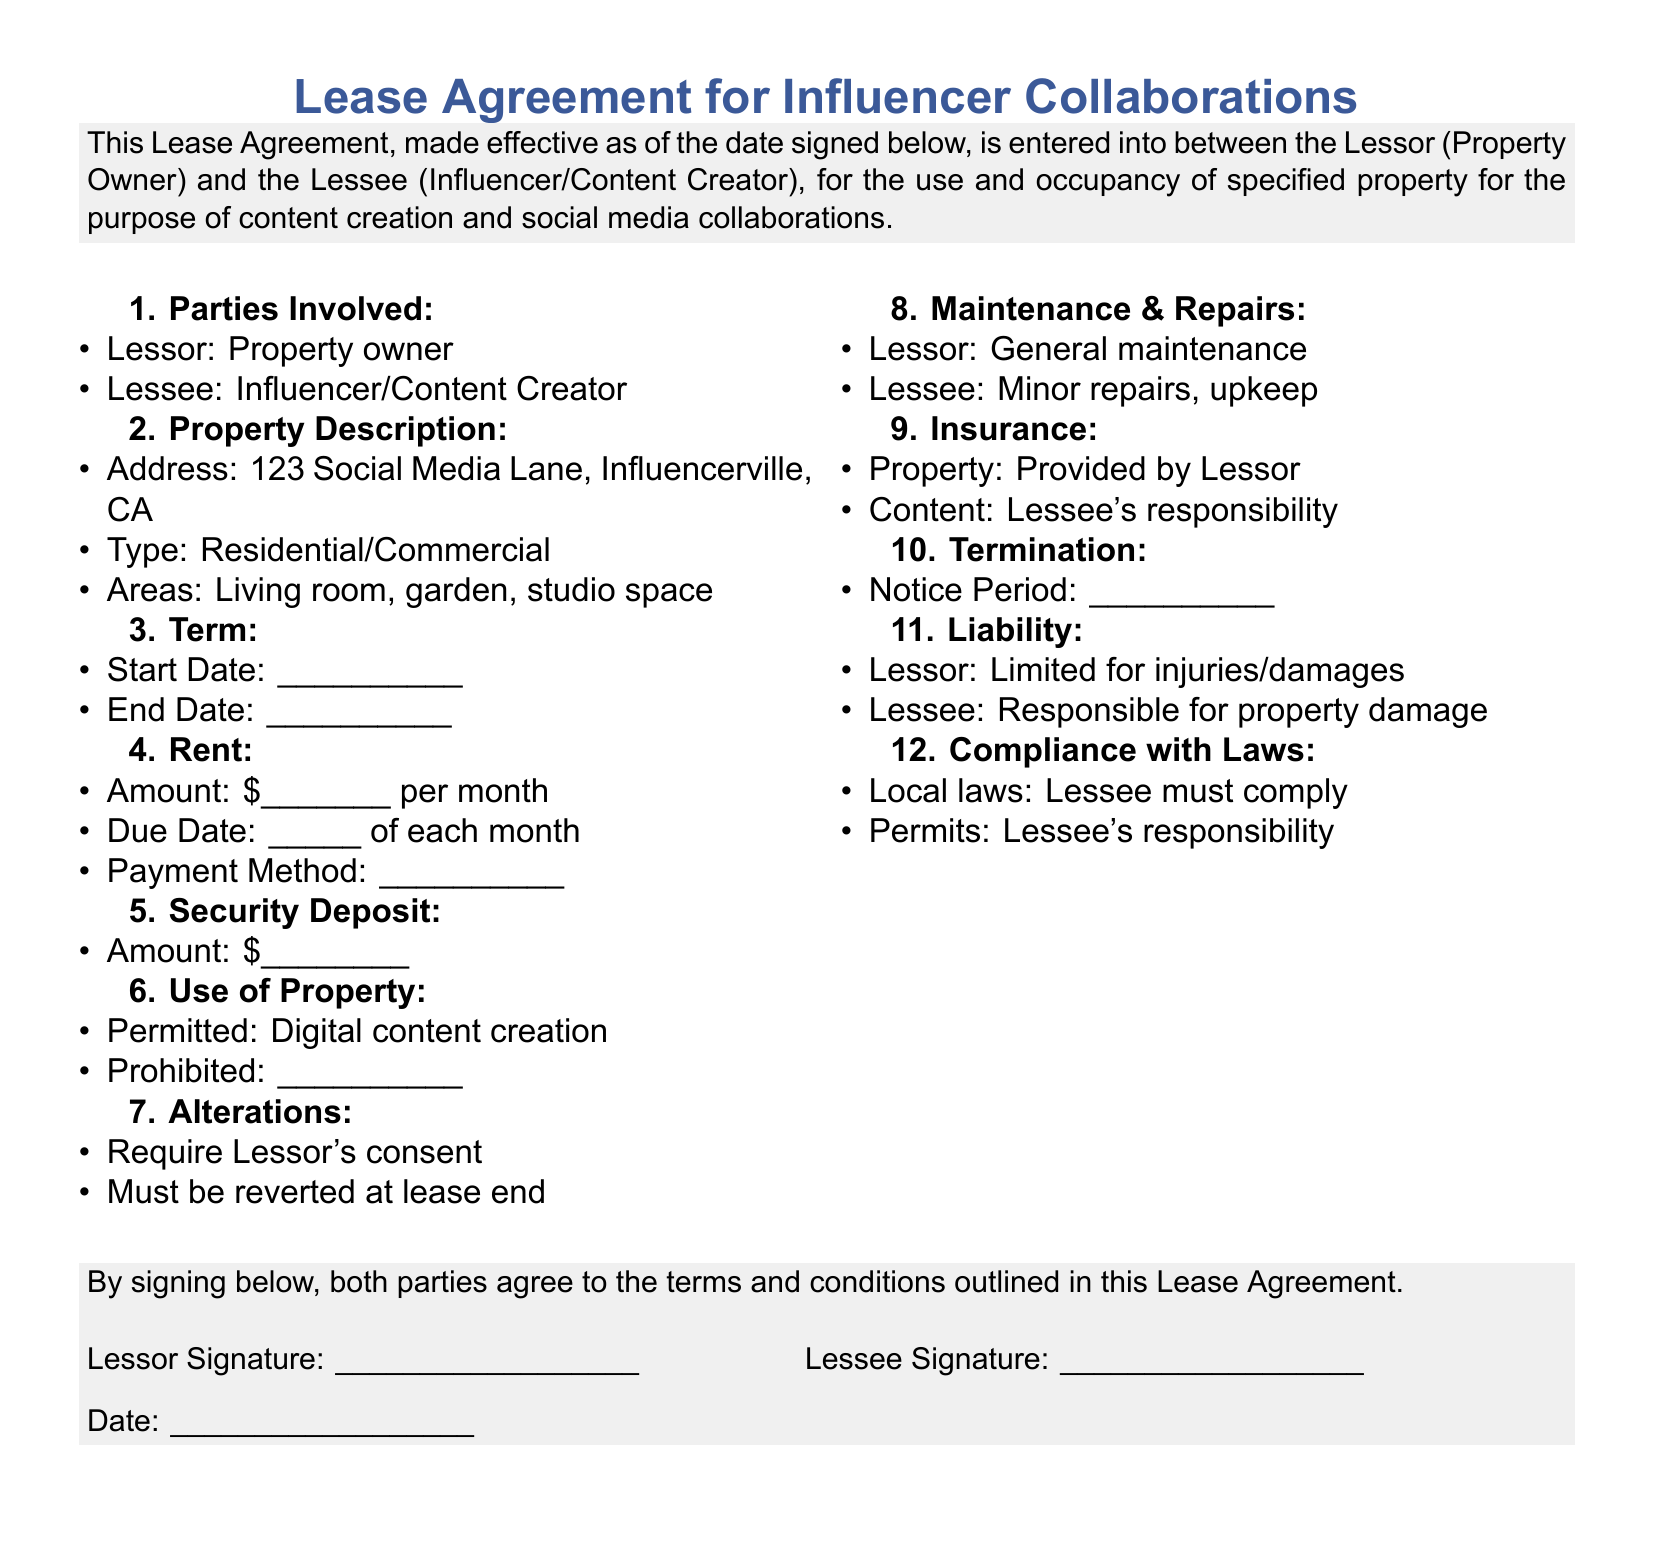What is the address of the property? The address of the property is specified in the Property Description section.
Answer: 123 Social Media Lane, Influencerville, CA Who are the parties involved in the lease agreement? The parties involved are listed at the beginning of the document.
Answer: Lessor and Lessee What is the start date of the lease? The start date is left blank for filling out in the document.
Answer: ____________ What type of content creation is permitted in the property? The permitted use of the property is stated in the Use of Property section.
Answer: Digital content creation What is the Lessee responsible for regarding insurance? The document specifies the responsibilities of the Lessee concerning insurance.
Answer: Content What must be obtained for alterations in the property? The Alterations section outlines what is necessary for making changes to the property.
Answer: Lessor's consent What kind of maintenance does the Lessor provide? The Maintenance & Repairs section mentions who handles general maintenance.
Answer: General maintenance How is liability for property damage assigned? The Liability section clarifies the responsibilities of each party concerning damages.
Answer: Lessee What is included in the security deposit amount? The amount for the security deposit is mentioned explicitly in the document.
Answer: $___________ 